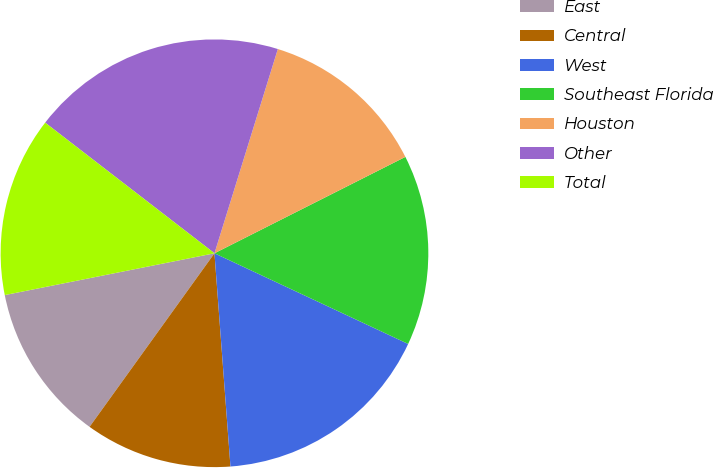Convert chart to OTSL. <chart><loc_0><loc_0><loc_500><loc_500><pie_chart><fcel>East<fcel>Central<fcel>West<fcel>Southeast Florida<fcel>Houston<fcel>Other<fcel>Total<nl><fcel>11.94%<fcel>11.12%<fcel>16.84%<fcel>14.41%<fcel>12.77%<fcel>19.33%<fcel>13.59%<nl></chart> 